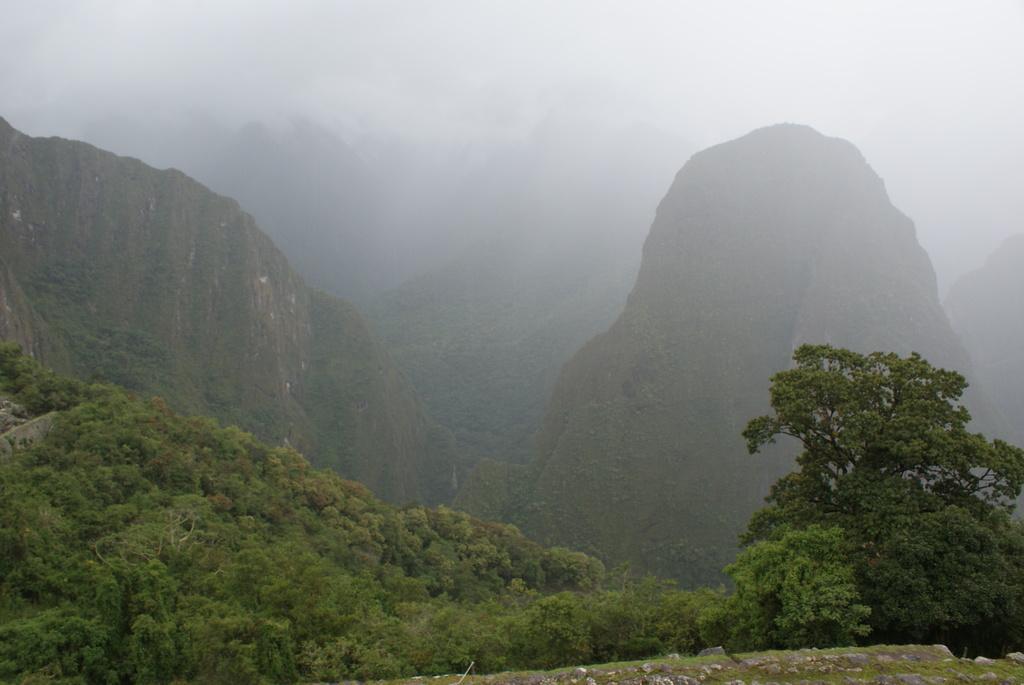How would you summarize this image in a sentence or two? This picture shows bunch of trees and we see hills and fog. 